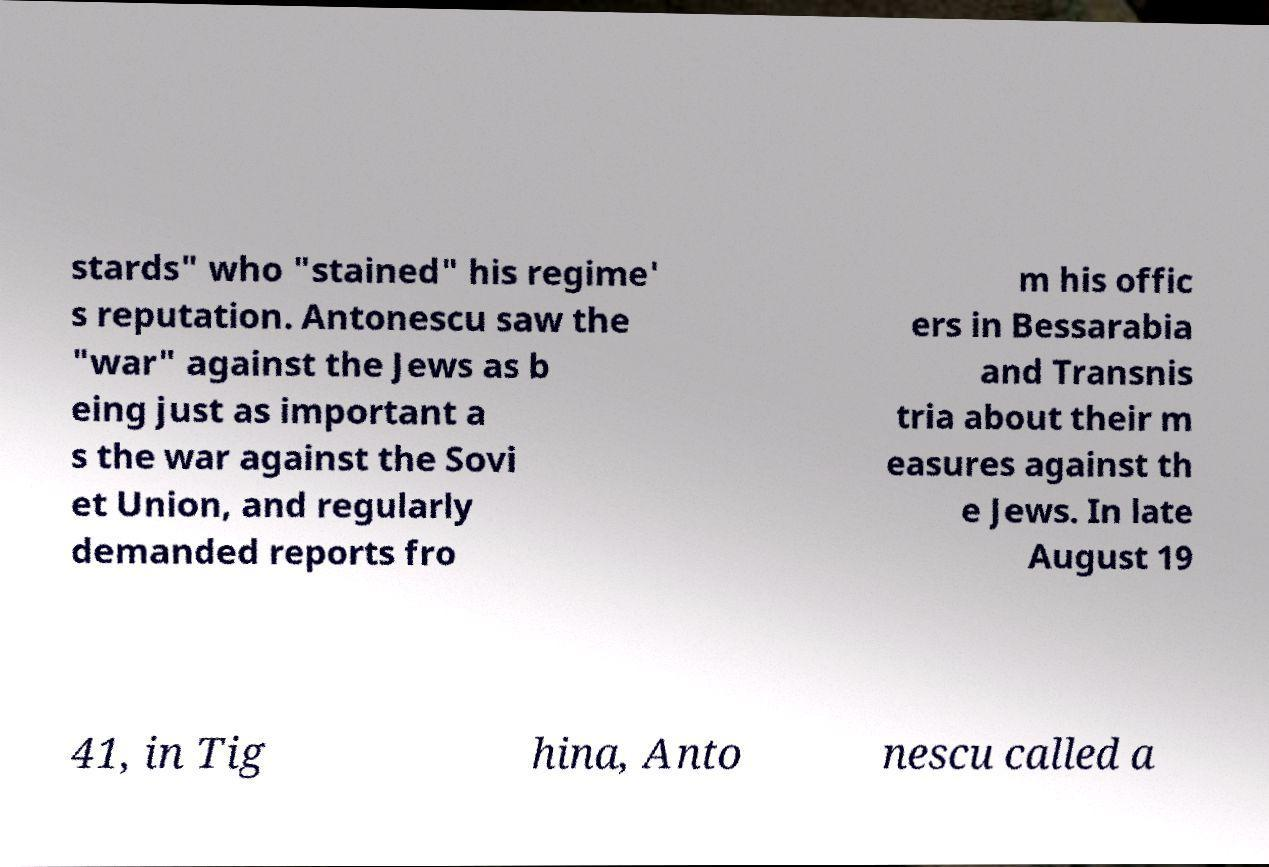For documentation purposes, I need the text within this image transcribed. Could you provide that? stards" who "stained" his regime' s reputation. Antonescu saw the "war" against the Jews as b eing just as important a s the war against the Sovi et Union, and regularly demanded reports fro m his offic ers in Bessarabia and Transnis tria about their m easures against th e Jews. In late August 19 41, in Tig hina, Anto nescu called a 